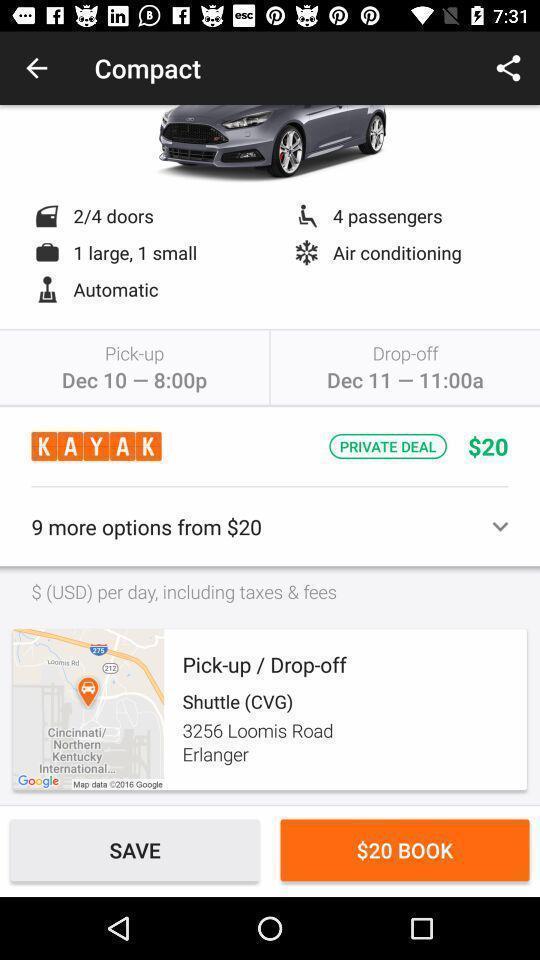Summarize the information in this screenshot. Page to book a car. 